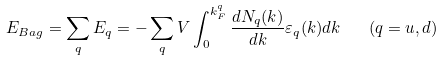Convert formula to latex. <formula><loc_0><loc_0><loc_500><loc_500>E _ { B a g } = \sum _ { q } E _ { q } = - \sum _ { q } V \int _ { 0 } ^ { k _ { F } ^ { q } } { \frac { d N _ { q } ( k ) } { d k } } \varepsilon _ { q } ( k ) d k \quad ( q = u , d )</formula> 